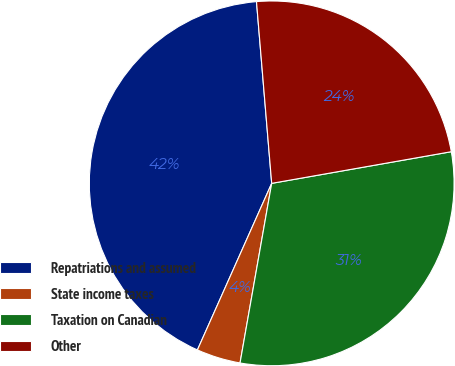Convert chart to OTSL. <chart><loc_0><loc_0><loc_500><loc_500><pie_chart><fcel>Repatriations and assumed<fcel>State income taxes<fcel>Taxation on Canadian<fcel>Other<nl><fcel>41.99%<fcel>3.9%<fcel>30.55%<fcel>23.55%<nl></chart> 